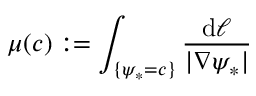Convert formula to latex. <formula><loc_0><loc_0><loc_500><loc_500>\mu ( c ) \colon = \int _ { \{ \psi _ { * } = c \} } \frac { d \ell } { | \nabla \psi _ { * } | }</formula> 